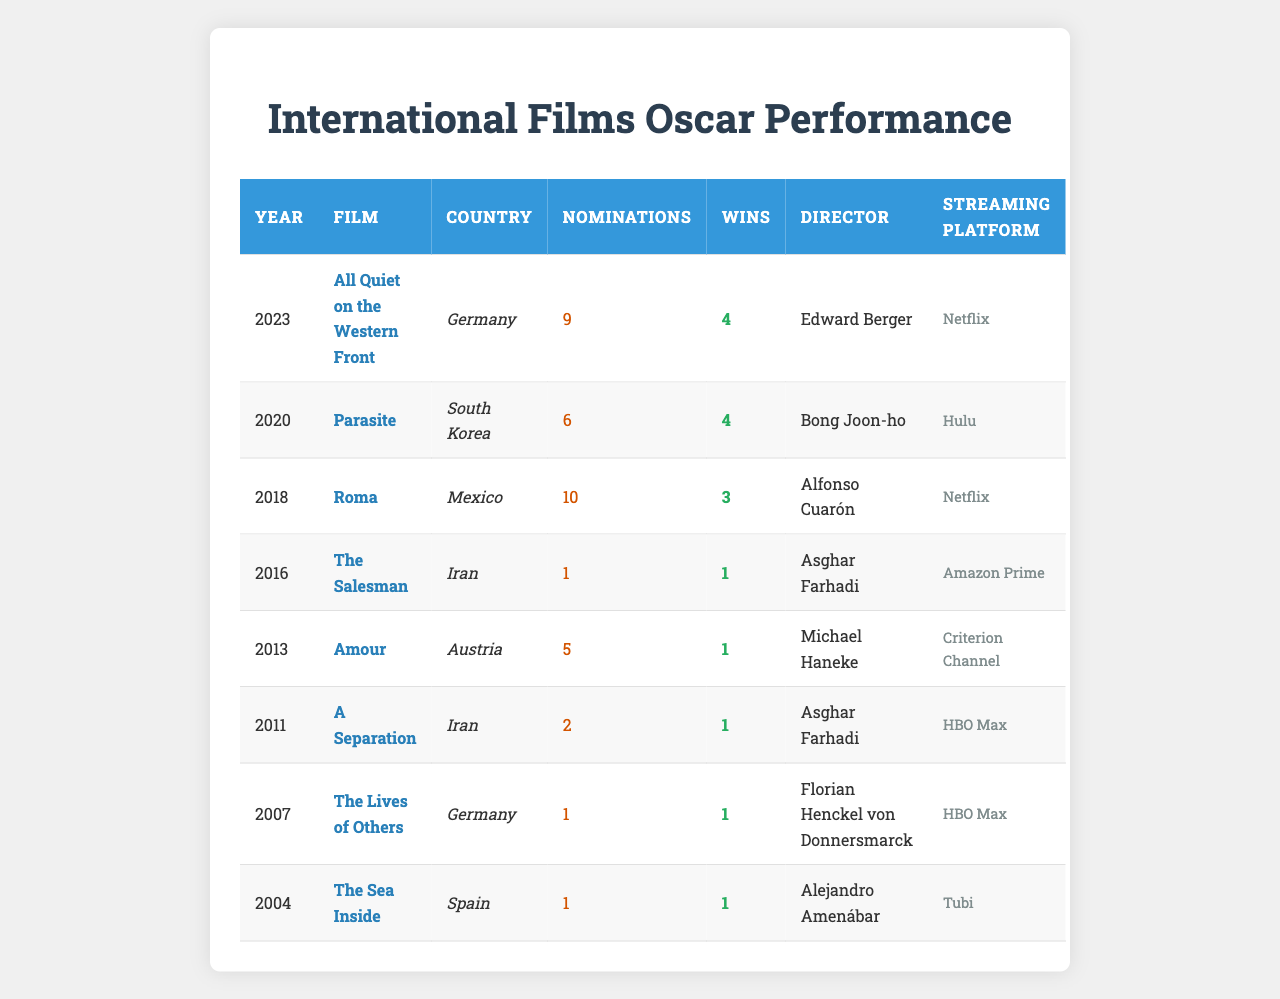What film received the most nominations in the past 20 years? By looking at the table, "Roma" from Mexico received the highest number of nominations with a total of 10.
Answer: Roma Which country won the most Oscars for international films in the last 20 years? Germany, represented by "All Quiet on the Western Front" and "The Lives of Others", won a total of 5 Oscars based on 4 wins (from 2023) and 1 win (from 2007).
Answer: Germany Did any Iranian films receive more than 2 nominations? No, the two Iranian films, "The Salesman" and "A Separation", each received only 2 or fewer nominations.
Answer: No What is the total number of wins for films from South Korea? "Parasite" won 4 Oscars, and there are no other South Korean films in the table, so the total number of wins is 4.
Answer: 4 Which film was nominated in 2018 and what was its streaming platform? The film nominated in 2018 was "Roma" and its streaming platform is Netflix.
Answer: Roma, Netflix Is it true that every nominated film from Germany has won at least 1 Oscar? Yes, both "The Lives of Others" and "All Quiet on the Western Front" were nominated and won 1 and 4 Oscars respectively, confirming that every film from Germany listed won at least once.
Answer: Yes How many films in the table were directed by Asghar Farhadi? There are two films directed by Asghar Farhadi: "The Salesman" and "A Separation."
Answer: 2 What is the average number of wins for the films listed in the table? The total number of wins is 4 (All Quiet on the Western Front) + 4 (Parasite) + 3 (Roma) + 1 (The Salesman) + 1 (Amour) + 1 (A Separation) + 1 (The Lives of Others) + 1 (The Sea Inside) = 16 wins. There are 8 films, so the average is 16/8 = 2.
Answer: 2 Which director has the highest number of nominations among the films listed? Since all listed films are considered separately and some films do not indicate nominations by the same director, it appears that only Alfonso Cuarón directed "Roma," which had 10 nominations. This indicates that he has the highest count.
Answer: Alfonso Cuarón Which film from Spain was nominated for an Oscar and what was its winning status? "The Sea Inside" was the film from Spain nominated for an Oscar, and it won 1 Oscar.
Answer: The Sea Inside, 1 win 